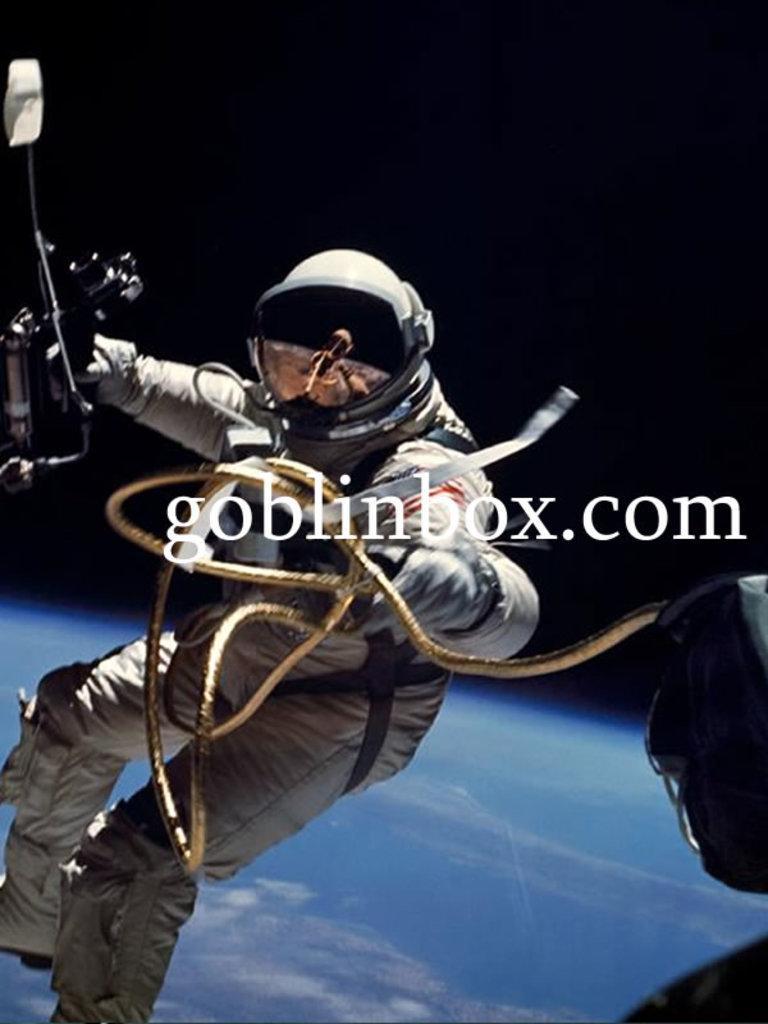Please provide a concise description of this image. In this image there is a man flying in the air, he is holding an object, there is text, there is an object towards the bottom of the image that looks like the sky, there are clouds in the sky, the background of the image is dark. 